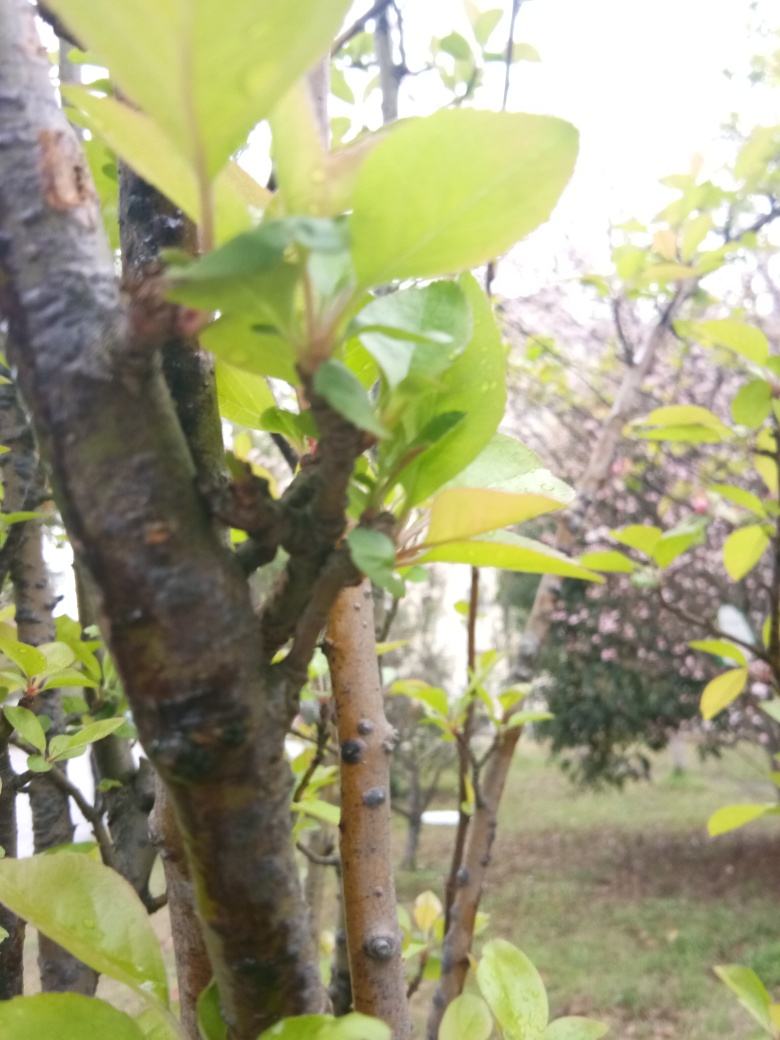Can you describe the health of the plant shown? While the focus on the foreground limits our observation, the leaves that are visible appear vibrant and undamaged, which suggests that the plant is healthy. Additionally, the new growth at the nodes of the branch indicates that the plant is actively growing. Is there anything in the image that suggests human care? There's no direct evidence of pruning or landscaping in the visible part of the image, so it's difficult to determine the level of human care. However, the organized layout of the plants may suggest a managed garden or park setting. 